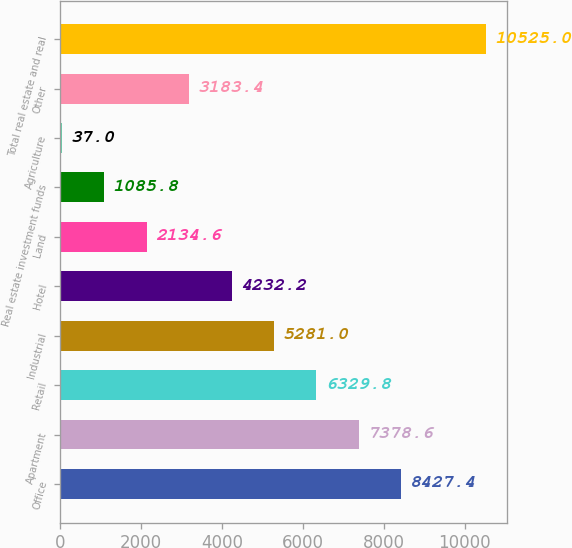Convert chart. <chart><loc_0><loc_0><loc_500><loc_500><bar_chart><fcel>Office<fcel>Apartment<fcel>Retail<fcel>Industrial<fcel>Hotel<fcel>Land<fcel>Real estate investment funds<fcel>Agriculture<fcel>Other<fcel>Total real estate and real<nl><fcel>8427.4<fcel>7378.6<fcel>6329.8<fcel>5281<fcel>4232.2<fcel>2134.6<fcel>1085.8<fcel>37<fcel>3183.4<fcel>10525<nl></chart> 